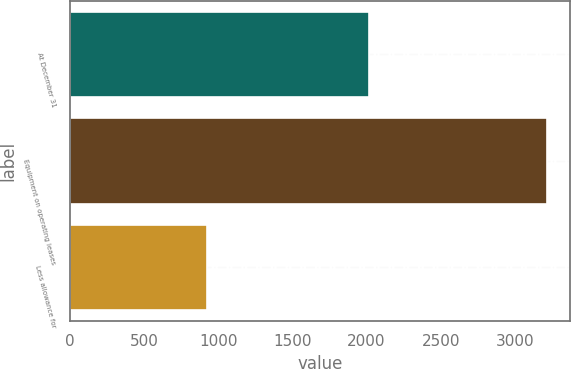Convert chart. <chart><loc_0><loc_0><loc_500><loc_500><bar_chart><fcel>At December 31<fcel>Equipment on operating leases<fcel>Less allowance for<nl><fcel>2013<fcel>3212.2<fcel>922.1<nl></chart> 